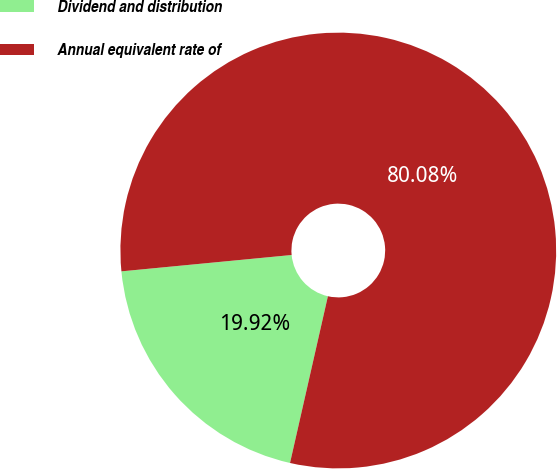Convert chart to OTSL. <chart><loc_0><loc_0><loc_500><loc_500><pie_chart><fcel>Dividend and distribution<fcel>Annual equivalent rate of<nl><fcel>19.92%<fcel>80.08%<nl></chart> 